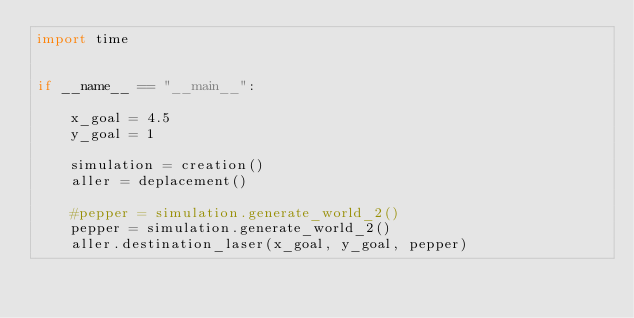Convert code to text. <code><loc_0><loc_0><loc_500><loc_500><_Python_>import time


if __name__ == "__main__":

    x_goal = 4.5
    y_goal = 1

    simulation = creation()
    aller = deplacement() 

    #pepper = simulation.generate_world_2()
    pepper = simulation.generate_world_2()
    aller.destination_laser(x_goal, y_goal, pepper)</code> 